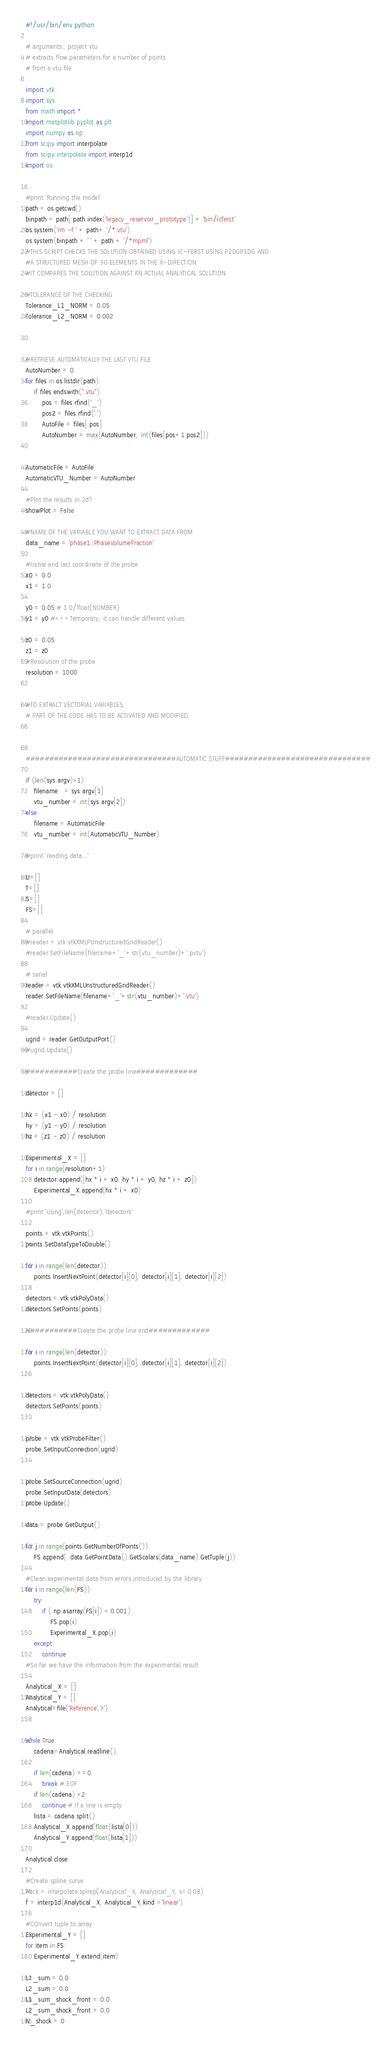<code> <loc_0><loc_0><loc_500><loc_500><_Python_>#!/usr/bin/env python

# arguments:: project vtu
# extracts flow parameters for a number of points
# from a vtu file

import vtk
import sys
from math import *
import matplotlib.pyplot as plt
import numpy as np
from scipy import interpolate
from scipy.interpolate import interp1d
import os


#print 'Running the model'
path = os.getcwd()
binpath = path[:path.index('legacy_reservoir_prototype')] + 'bin/icferst'
os.system('rm -f ' + path+ '/*.vtu')
os.system(binpath + ' ' + path + '/*mpml')
#THIS SCRIPT CHECKS THE SOLUTION OBTAINED USING IC-FERST USING P2DGP1DG AND 
#A STRUCTURED MESH OF 30 ELEMENTS IN THE X-DIRECTION
#IT COMPARES THE SOLUTION AGAINST AN ACTUAL ANALYTICAL SOLUTION

#TOLERANCE OF THE CHECKING
Tolerance_L1_NORM = 0.05
Tolerance_L2_NORM = 0.002



#RETRIEVE AUTOMATICALLY THE LAST VTU FILE
AutoNumber = 0
for files in os.listdir(path):
    if files.endswith(".vtu"):
        pos = files.rfind('_')
        pos2 = files.rfind('.')
        AutoFile = files[:pos]
        AutoNumber = max(AutoNumber, int(files[pos+1:pos2]))


AutomaticFile = AutoFile
AutomaticVTU_Number = AutoNumber

#Plot the results in 2d?
showPlot = False

#NAME OF THE VARIABLE YOU WANT TO EXTRACT DATA FROM
data_name = 'phase1::PhaseVolumeFraction'

#Initial and last coordinate of the probe
x0 = 0.0
x1 = 1.0

y0 = 0.05 # 1.0/float(NUMBER)
y1 = y0 #<==Temporary, it can handle different values

z0 = 0.05
z1 = z0
#Resolution of the probe
resolution = 1000


#TO EXTRACT VECTORIAL VARIABLES,
# PART OF THE CODE HAS TO BE ACTIVATED AND MODIFIED

   

################################AUTOMATIC STUFF###############################

if (len(sys.argv)>1):
    filename   = sys.argv[1]
    vtu_number = int(sys.argv[2])
else:
    filename = AutomaticFile
    vtu_number = int(AutomaticVTU_Number)
    
#print 'reading data...'

U=[]
T=[]
S=[]
FS=[]

# parallel
#reader = vtk.vtkXMLPUnstructuredGridReader()
#reader.SetFileName(filename+'_'+str(vtu_number)+'.pvtu')

# serial
reader = vtk.vtkXMLUnstructuredGridReader()
reader.SetFileName(filename+'_'+str(vtu_number)+'.vtu')

#reader.Update()

ugrid = reader.GetOutputPort()
#ugrid.Update()

###########Create the probe line#############
        
detector = []

hx = (x1 - x0) / resolution
hy = (y1 - y0) / resolution
hz = (z1 - z0) / resolution

Experimental_X = []
for i in range(resolution+1):
    detector.append([hx * i + x0, hy * i + y0, hz * i + z0])
    Experimental_X.append(hx * i + x0)

#print 'using',len(detector),'detectors'

points = vtk.vtkPoints()
points.SetDataTypeToDouble()

for i in range(len(detector)):
    points.InsertNextPoint(detector[i][0], detector[i][1], detector[i][2])

detectors = vtk.vtkPolyData()
detectors.SetPoints(points)    

###########Create the probe line end#############

for i in range(len(detector)):
    points.InsertNextPoint(detector[i][0], detector[i][1], detector[i][2])


detectors = vtk.vtkPolyData()
detectors.SetPoints(points)


probe = vtk.vtkProbeFilter()
probe.SetInputConnection(ugrid)


probe.SetSourceConnection(ugrid)
probe.SetInputData(detectors)
probe.Update()

data = probe.GetOutput()

for j in range(points.GetNumberOfPoints()):
    FS.append(  data.GetPointData().GetScalars(data_name).GetTuple(j))

#Clean experimental data from errors introduced by the library
for i in range(len(FS)):
    try:
        if ( np.asarray(FS[i]) < 0.001):
            FS.pop(i)
            Experimental_X.pop(i)
    except:
        continue
#So far we have the information from the experimental result

Analytical_X = []
Analytical_Y = []
Analytical=file('Reference','r')


while True:
    cadena=Analytical.readline()

    if len(cadena) ==0:
        break # EOF
    if len(cadena) <2:
        continue # If a line is empty       
    lista = cadena.split()
    Analytical_X.append(float(lista[0]))
    Analytical_Y.append(float(lista[1]))

Analytical.close

#Create spline curve
#tck = interpolate.splrep(Analytical_X, Analytical_Y, s=0.08)
f = interp1d(Analytical_X, Analytical_Y,kind ='linear')

#COnvert tuple to array
Experimental_Y = []
for item in FS:
    Experimental_Y.extend(item)

L1_sum = 0.0
L2_sum = 0.0
L1_sum_shock_front = 0.0
L2_sum_shock_front = 0.0
N_shock = 0</code> 